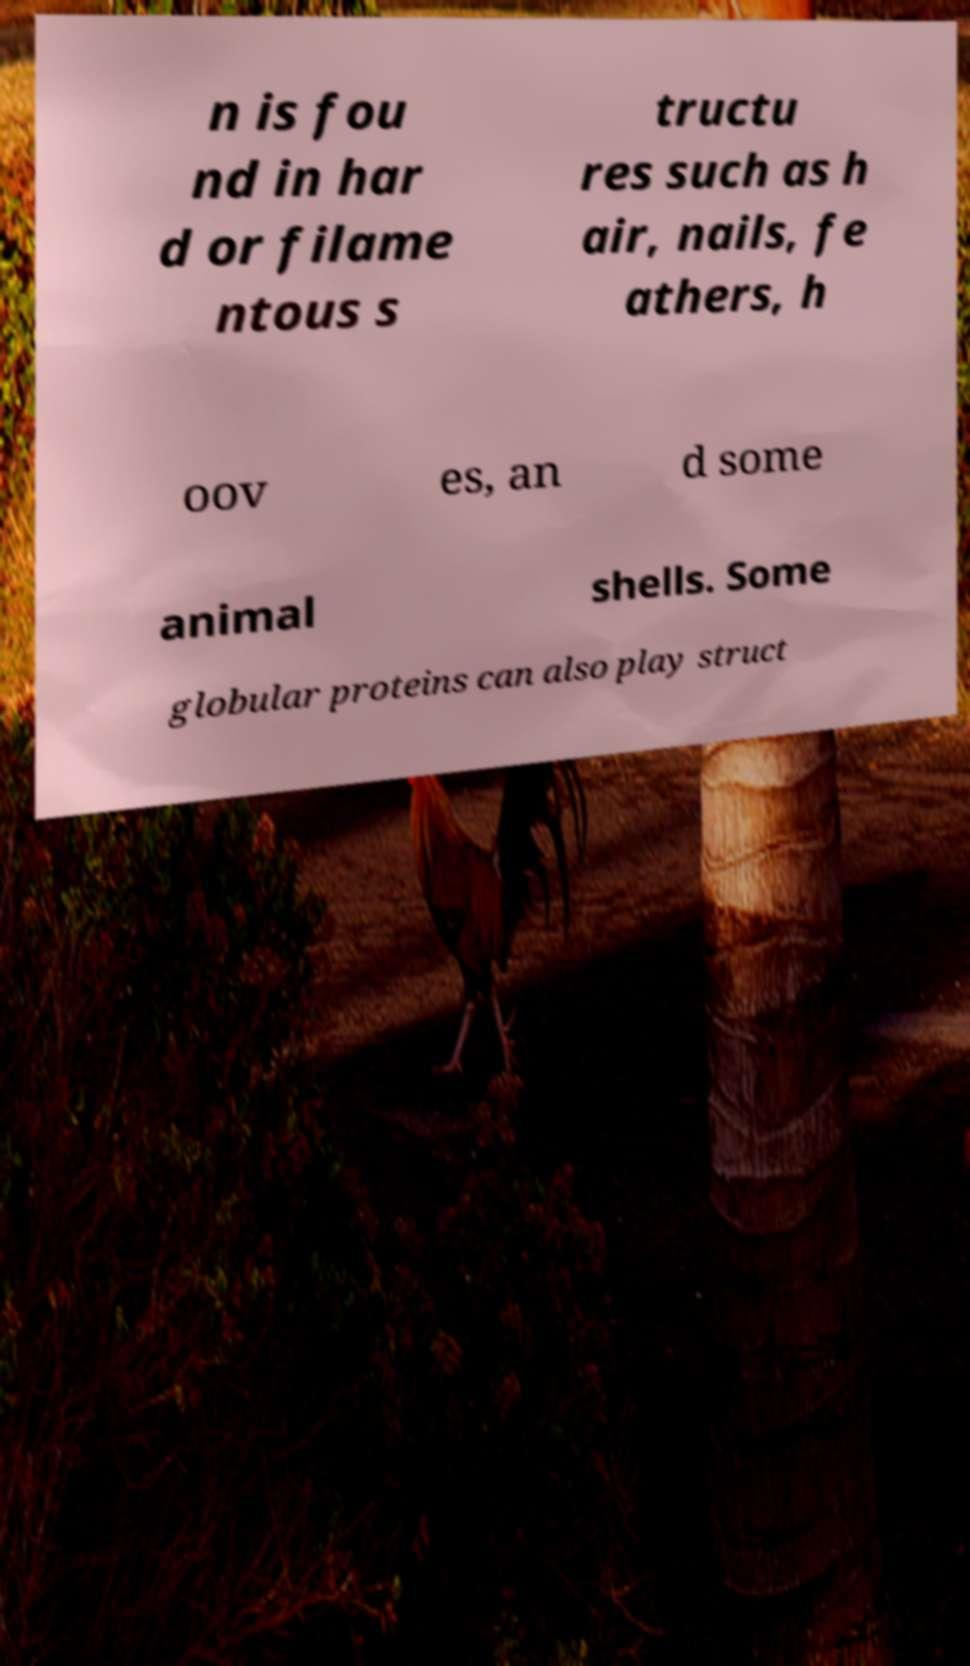What messages or text are displayed in this image? I need them in a readable, typed format. n is fou nd in har d or filame ntous s tructu res such as h air, nails, fe athers, h oov es, an d some animal shells. Some globular proteins can also play struct 